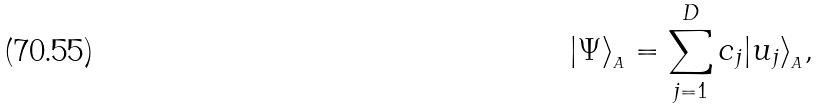Convert formula to latex. <formula><loc_0><loc_0><loc_500><loc_500>| \Psi \rangle _ { _ { A } } = \sum _ { j = 1 } ^ { D } c _ { j } | u _ { j } \rangle _ { _ { A } } ,</formula> 